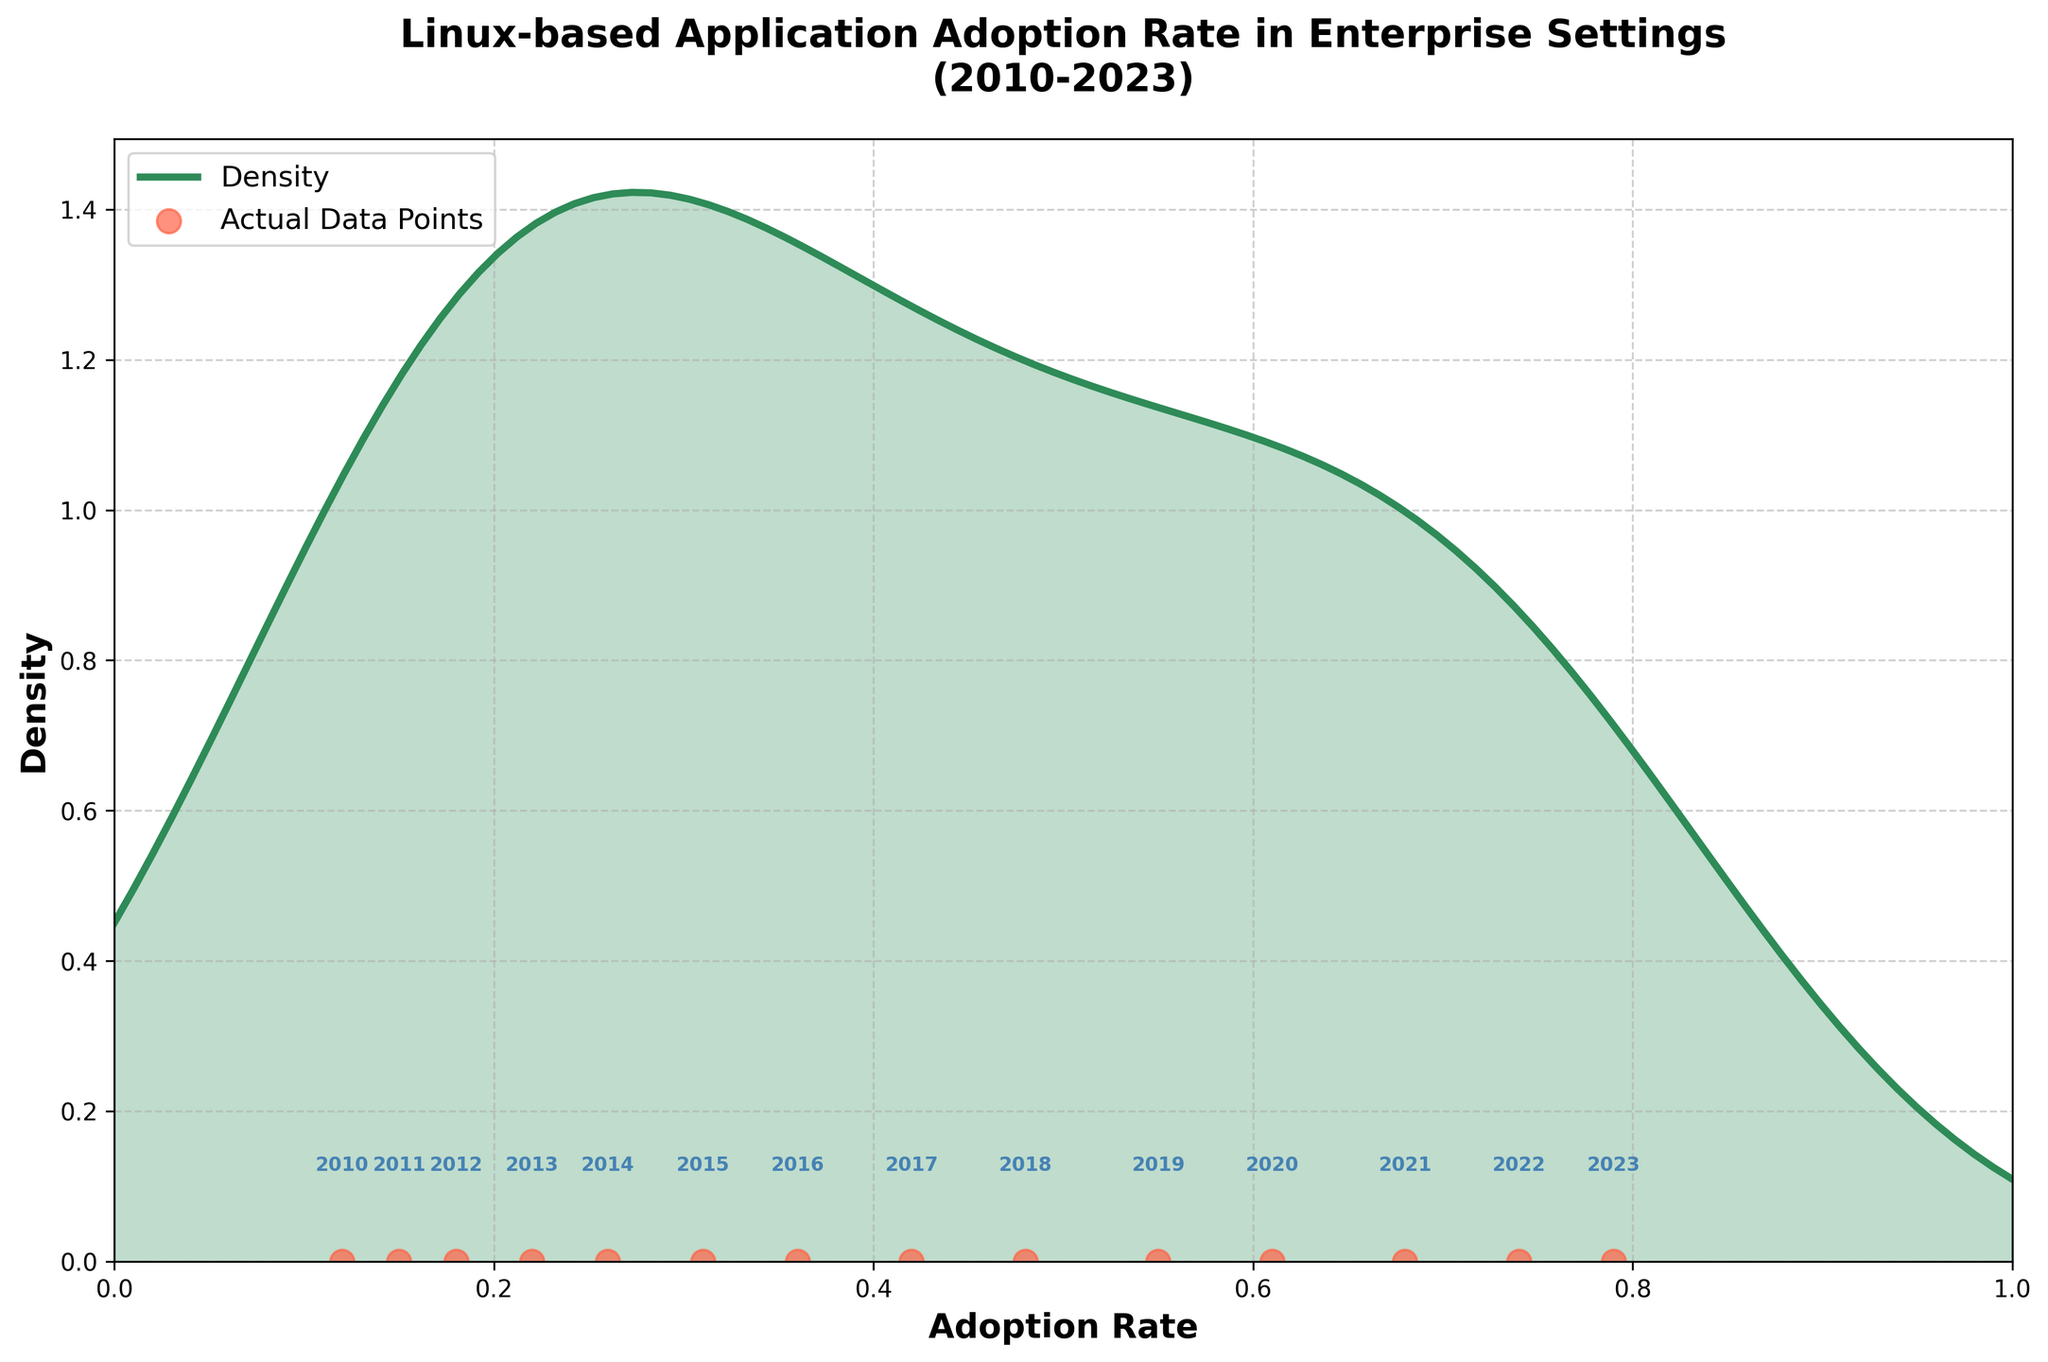What is the title of the figure? The title can be found at the top of the figure. It summarizes the main subject of the figure. The title in this case is "Linux-based Application Adoption Rate in Enterprise Settings (2010-2023)".
Answer: "Linux-based Application Adoption Rate in Enterprise Settings (2010-2023)" What are the labels on the x and y axes? The labels on the axes describe what each axis represents. Here, the x-axis is labeled "Adoption Rate" and the y-axis is labeled "Density".
Answer: "Adoption Rate" and "Density" How many data points are plotted on the density curve? The data points can be identified by the scatter plot elements marked along the x-axis. Counting these points gives us a total of 14 data points.
Answer: 14 Which year has the highest adoption rate according to the plot? To find this, we look for the data point positioned furthest to the right on the x-axis. The label indicates it is the year 2023.
Answer: 2023 Between which years did the adoption rate first exceed 50%? Check the labels on the x-axis and find the adoption rate that surpasses 0.50. It shows that the adoption rate exceeded 50% between 2018 and 2019.
Answer: 2018 and 2019 What is the trend of the adoption rate from 2010 to 2023? Observing the scatter plot points from left to right shows that the adoption rate increases steadily without any decline from 2010 to 2023.
Answer: Steadily increasing Is there any year where the adoption rate decreased compared to the previous year? By observing the scatter points and their positions along the x-axis, there is no decrease in the adoption rate for any year; it just keeps increasing.
Answer: No How does the density change as the adoption rate increases? Examining the density curve, it starts low, increases to a peak, and then gradually decreases. This indicates that there are more data points concentrated in the middle range of adoption rates.
Answer: Increases to a peak then decreases What is the approximate density value at an adoption rate of 0.7? By locating the x-axis value of 0.7 and moving vertically to intersect the density curve, it can be approximated that the density value is around 1.2.
Answer: Around 1.2 Which year corresponds to an adoption rate closest to the peak density value? The peak density is near the x-axis value for 0.55–0.60 (closest to 0.61). From the scatter plot points, 2020 corresponds to an adoption rate of 0.61.
Answer: 2020 